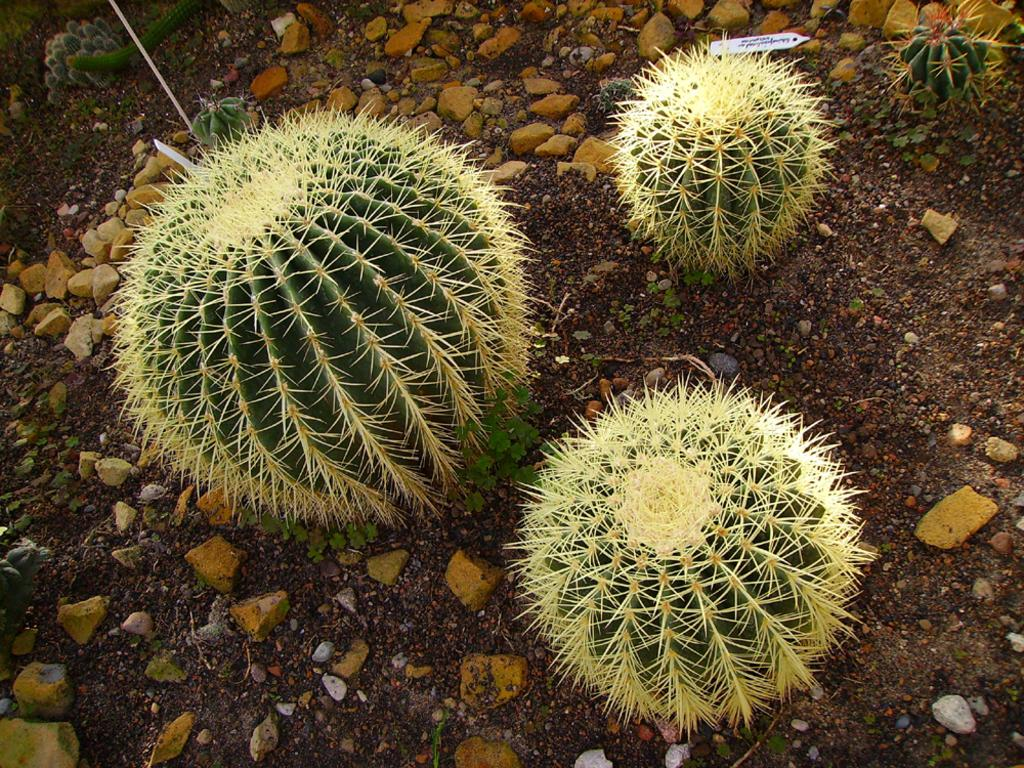What type of plant is in the image? There is a ball cactus in the image. Where is the ball cactus located? The ball cactus is on the ground. What is the ground covered with? The ground is covered with stones. What type of engine can be seen powering the ball cactus in the image? There is no engine present in the image, and the ball cactus is a plant, not a machine that requires an engine. 